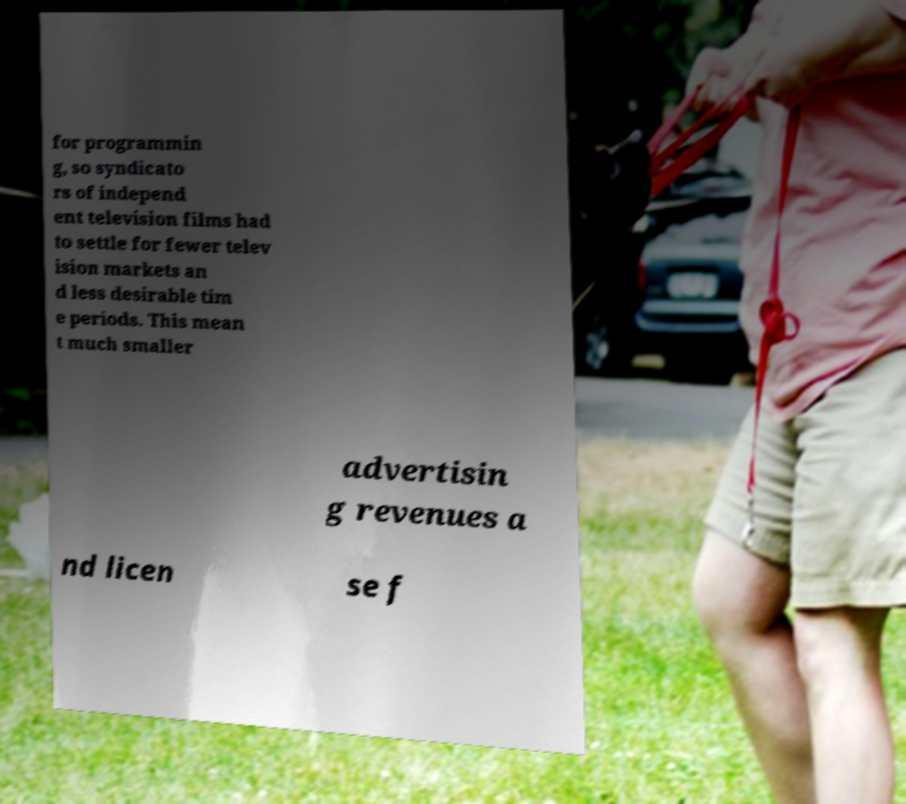Can you read and provide the text displayed in the image?This photo seems to have some interesting text. Can you extract and type it out for me? for programmin g, so syndicato rs of independ ent television films had to settle for fewer telev ision markets an d less desirable tim e periods. This mean t much smaller advertisin g revenues a nd licen se f 